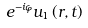Convert formula to latex. <formula><loc_0><loc_0><loc_500><loc_500>e ^ { - i \varphi } u _ { 1 } \left ( r , t \right ) \\</formula> 